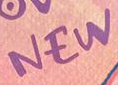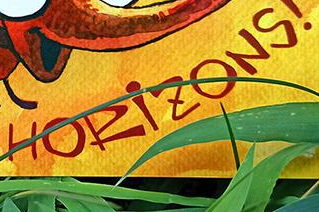What words can you see in these images in sequence, separated by a semicolon? NEW; HORiZONS 